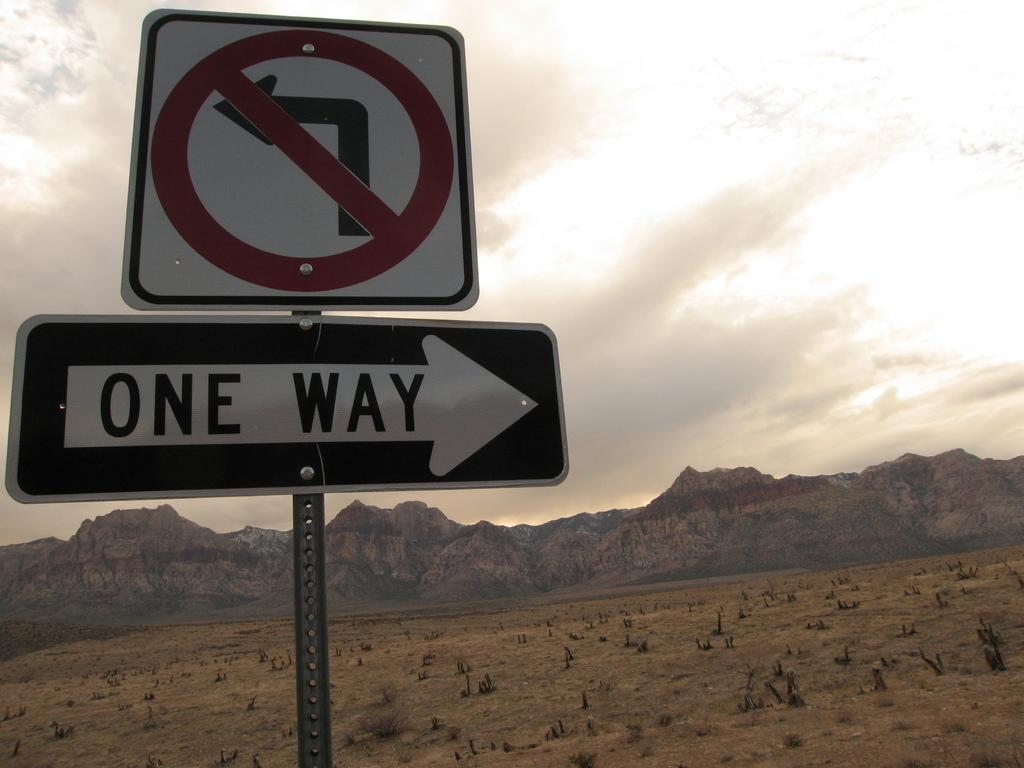<image>
Summarize the visual content of the image. A one way sign pointing to the right. 